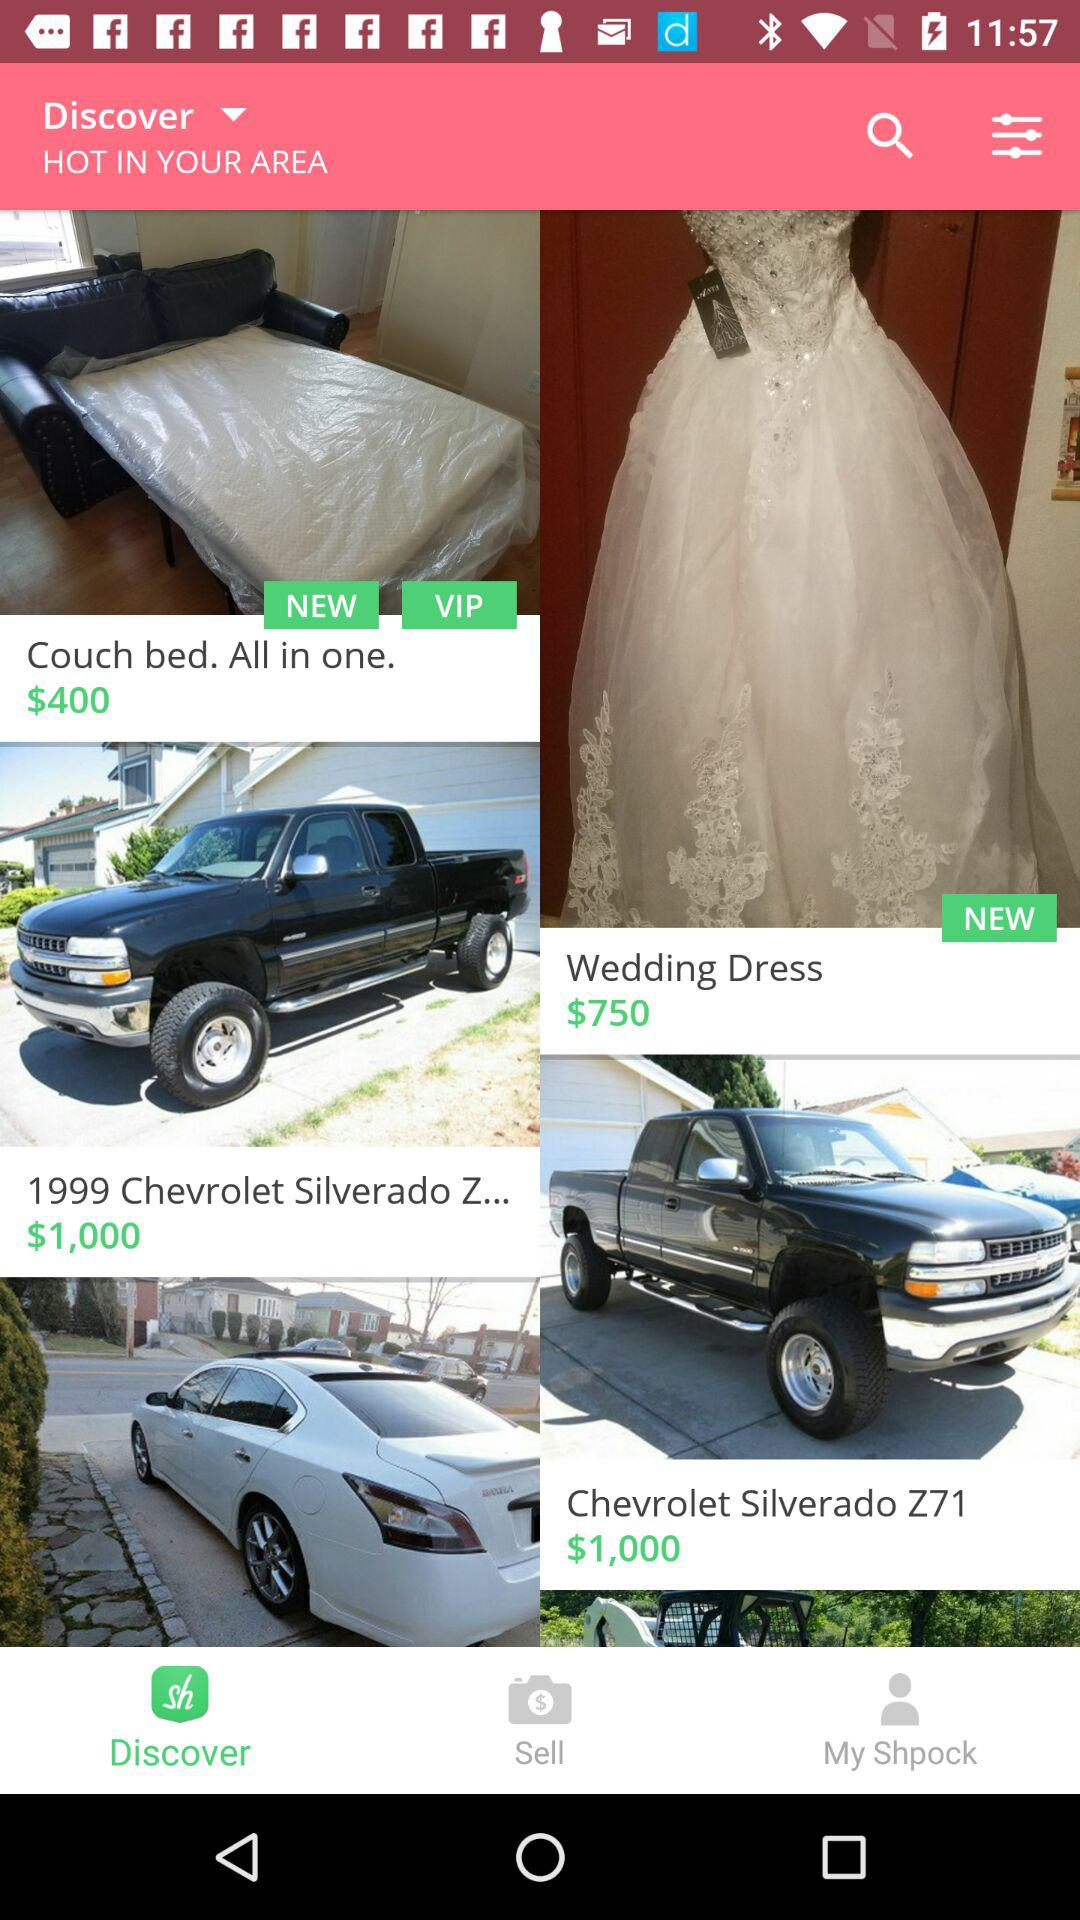How many items have a price of $1,000?
Answer the question using a single word or phrase. 2 